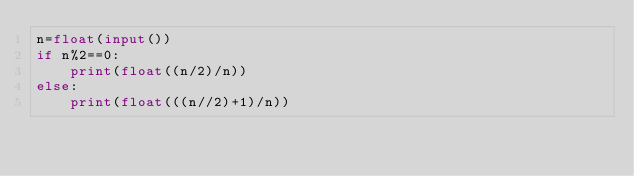<code> <loc_0><loc_0><loc_500><loc_500><_Python_>n=float(input())
if n%2==0:
    print(float((n/2)/n))
else:
    print(float(((n//2)+1)/n))</code> 